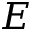Convert formula to latex. <formula><loc_0><loc_0><loc_500><loc_500>E</formula> 